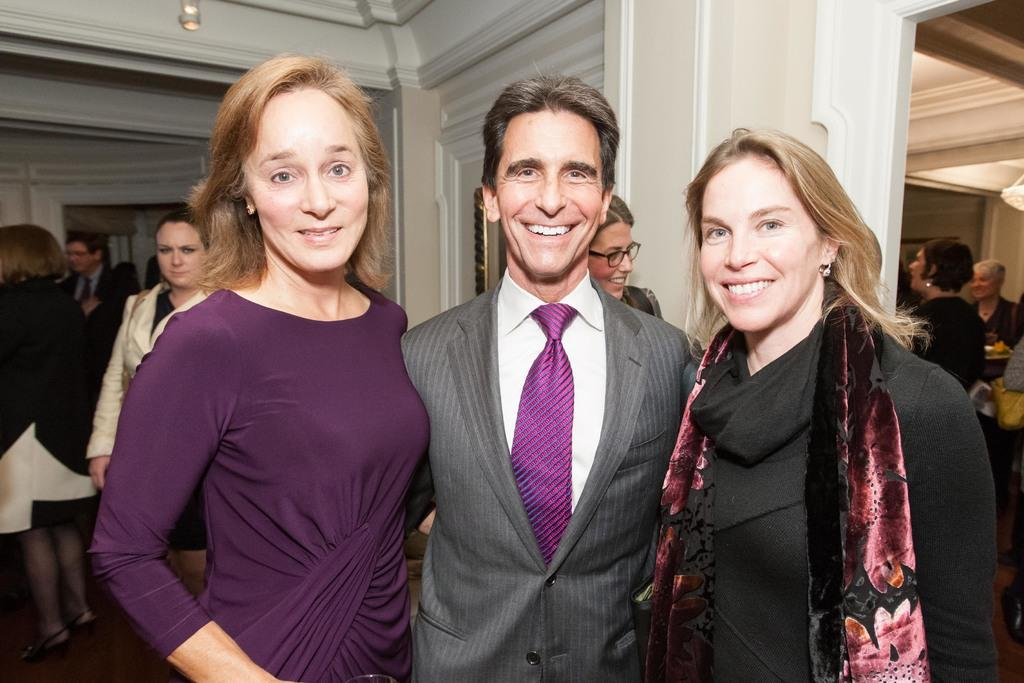How many people are standing and smiling in the image? There are three persons standing and smiling in the image. Can you describe the people in the background of the image? There is a group of people standing in the background of the image. What type of lighting fixture is visible in the image? There is a chandelier visible in the image. How many baby rabbits can be seen playing in the image? There are no baby rabbits present in the image. 